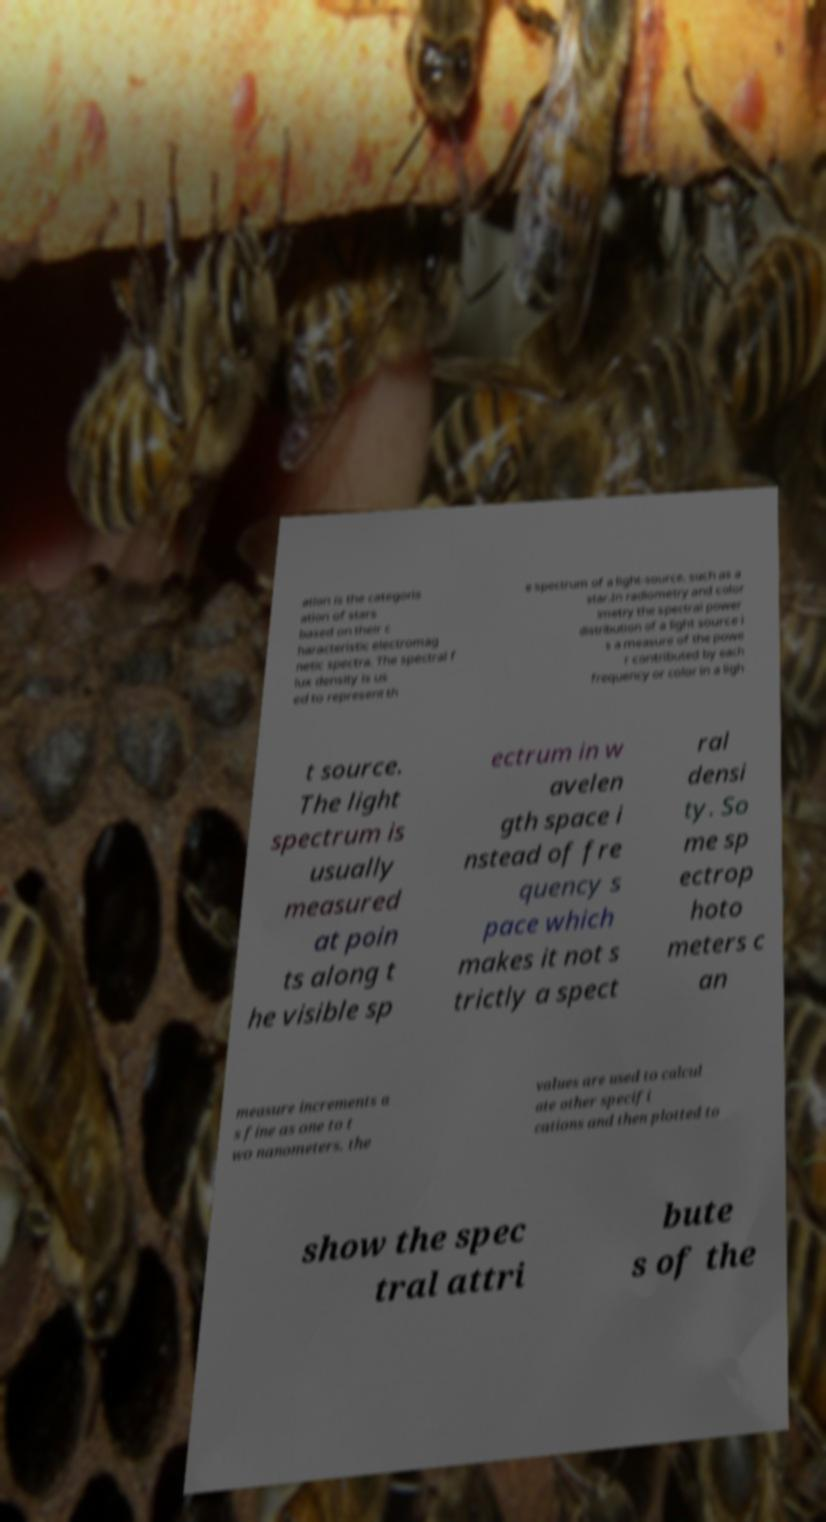Can you accurately transcribe the text from the provided image for me? ation is the categoris ation of stars based on their c haracteristic electromag netic spectra. The spectral f lux density is us ed to represent th e spectrum of a light-source, such as a star.In radiometry and color imetry the spectral power distribution of a light source i s a measure of the powe r contributed by each frequency or color in a ligh t source. The light spectrum is usually measured at poin ts along t he visible sp ectrum in w avelen gth space i nstead of fre quency s pace which makes it not s trictly a spect ral densi ty. So me sp ectrop hoto meters c an measure increments a s fine as one to t wo nanometers. the values are used to calcul ate other specifi cations and then plotted to show the spec tral attri bute s of the 